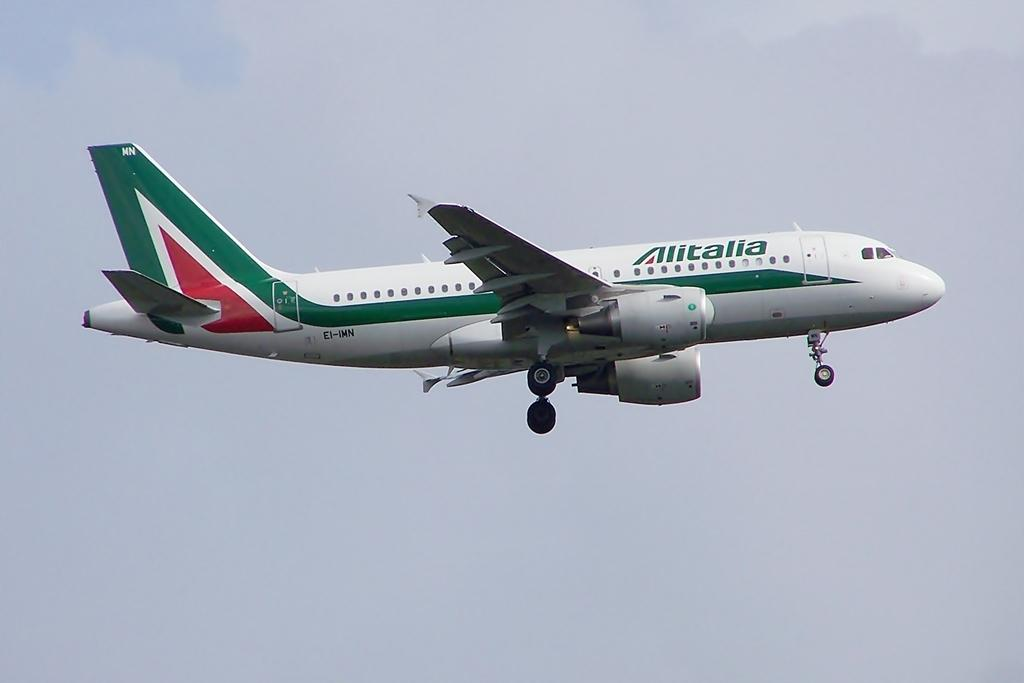<image>
Summarize the visual content of the image. A green, red, and white Alitalia airplane is flying in the air. 